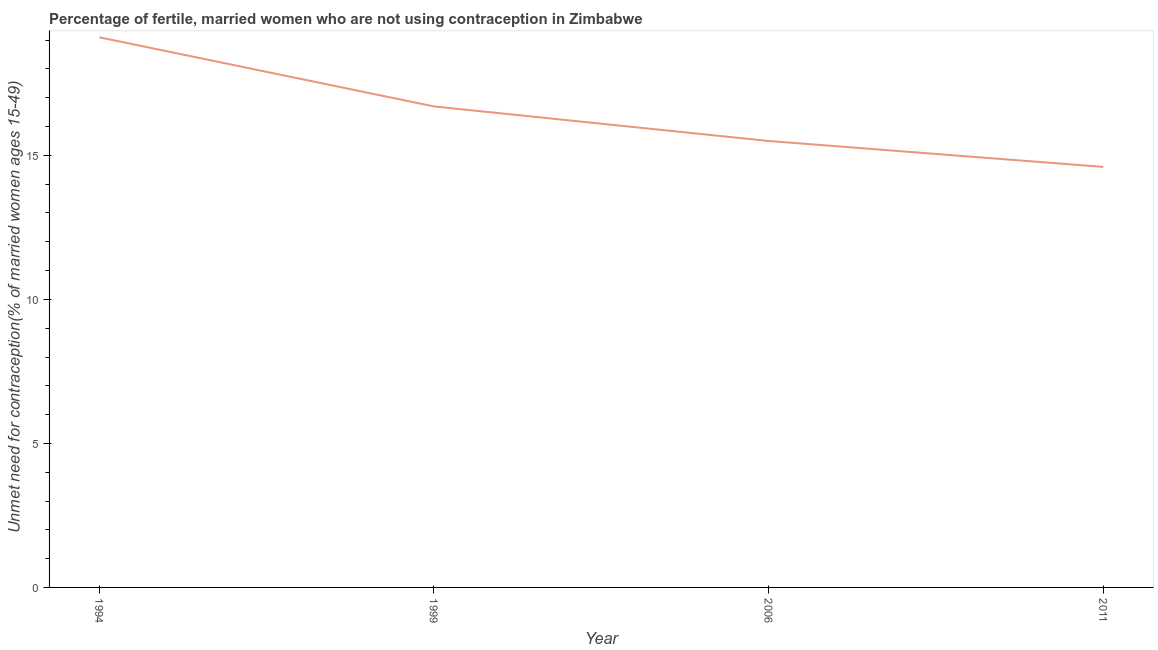What is the number of married women who are not using contraception in 2006?
Give a very brief answer. 15.5. Across all years, what is the minimum number of married women who are not using contraception?
Provide a succinct answer. 14.6. In which year was the number of married women who are not using contraception maximum?
Your answer should be very brief. 1994. What is the sum of the number of married women who are not using contraception?
Offer a terse response. 65.9. What is the difference between the number of married women who are not using contraception in 1994 and 1999?
Provide a succinct answer. 2.4. What is the average number of married women who are not using contraception per year?
Offer a very short reply. 16.47. What is the median number of married women who are not using contraception?
Give a very brief answer. 16.1. In how many years, is the number of married women who are not using contraception greater than 7 %?
Keep it short and to the point. 4. Do a majority of the years between 2006 and 1994 (inclusive) have number of married women who are not using contraception greater than 17 %?
Give a very brief answer. No. What is the ratio of the number of married women who are not using contraception in 1999 to that in 2011?
Offer a terse response. 1.14. Is the number of married women who are not using contraception in 1999 less than that in 2006?
Provide a short and direct response. No. What is the difference between the highest and the second highest number of married women who are not using contraception?
Provide a short and direct response. 2.4. What is the difference between the highest and the lowest number of married women who are not using contraception?
Keep it short and to the point. 4.5. In how many years, is the number of married women who are not using contraception greater than the average number of married women who are not using contraception taken over all years?
Provide a short and direct response. 2. How many lines are there?
Make the answer very short. 1. How many years are there in the graph?
Offer a very short reply. 4. Are the values on the major ticks of Y-axis written in scientific E-notation?
Your response must be concise. No. What is the title of the graph?
Your answer should be compact. Percentage of fertile, married women who are not using contraception in Zimbabwe. What is the label or title of the Y-axis?
Offer a terse response.  Unmet need for contraception(% of married women ages 15-49). What is the  Unmet need for contraception(% of married women ages 15-49) of 2011?
Provide a succinct answer. 14.6. What is the difference between the  Unmet need for contraception(% of married women ages 15-49) in 1994 and 1999?
Your answer should be compact. 2.4. What is the difference between the  Unmet need for contraception(% of married women ages 15-49) in 1994 and 2006?
Give a very brief answer. 3.6. What is the difference between the  Unmet need for contraception(% of married women ages 15-49) in 1994 and 2011?
Make the answer very short. 4.5. What is the difference between the  Unmet need for contraception(% of married women ages 15-49) in 2006 and 2011?
Provide a short and direct response. 0.9. What is the ratio of the  Unmet need for contraception(% of married women ages 15-49) in 1994 to that in 1999?
Keep it short and to the point. 1.14. What is the ratio of the  Unmet need for contraception(% of married women ages 15-49) in 1994 to that in 2006?
Provide a succinct answer. 1.23. What is the ratio of the  Unmet need for contraception(% of married women ages 15-49) in 1994 to that in 2011?
Ensure brevity in your answer.  1.31. What is the ratio of the  Unmet need for contraception(% of married women ages 15-49) in 1999 to that in 2006?
Give a very brief answer. 1.08. What is the ratio of the  Unmet need for contraception(% of married women ages 15-49) in 1999 to that in 2011?
Give a very brief answer. 1.14. What is the ratio of the  Unmet need for contraception(% of married women ages 15-49) in 2006 to that in 2011?
Give a very brief answer. 1.06. 